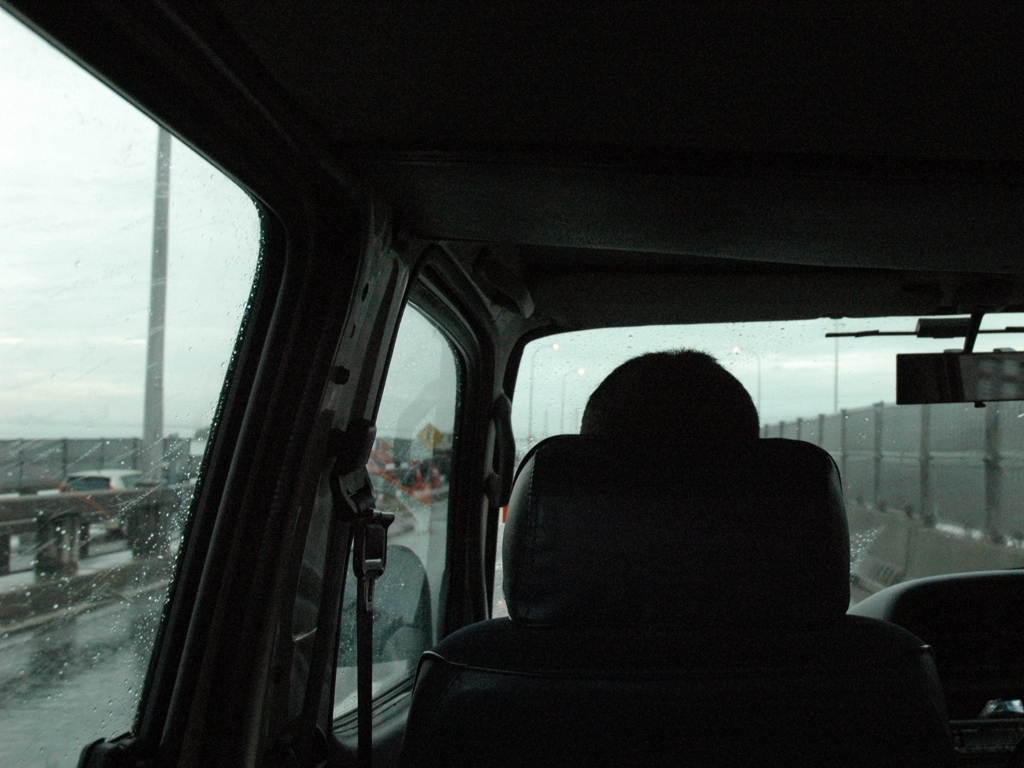Is the focus unacceptable? The focus appears to be intentionally set to capture the somber mood of a rainy journey from inside a vehicle, with the silhouette of a person's back and the rainy window suggesting reflection and travel. While it may not be crisp, the focus effectively conveys the intended atmosphere. 